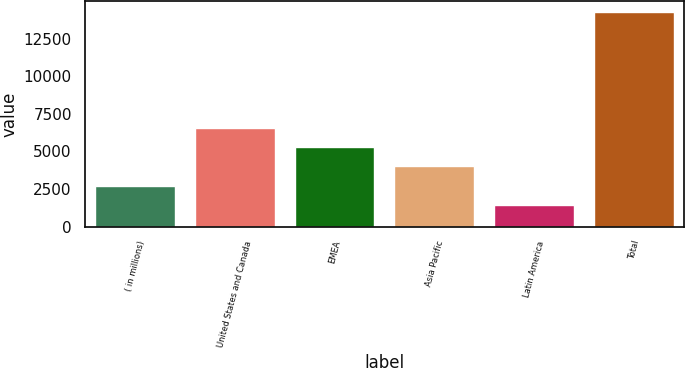<chart> <loc_0><loc_0><loc_500><loc_500><bar_chart><fcel>( in millions)<fcel>United States and Canada<fcel>EMEA<fcel>Asia Pacific<fcel>Latin America<fcel>Total<nl><fcel>2705.9<fcel>6560.6<fcel>5275.7<fcel>3990.8<fcel>1421<fcel>14270<nl></chart> 